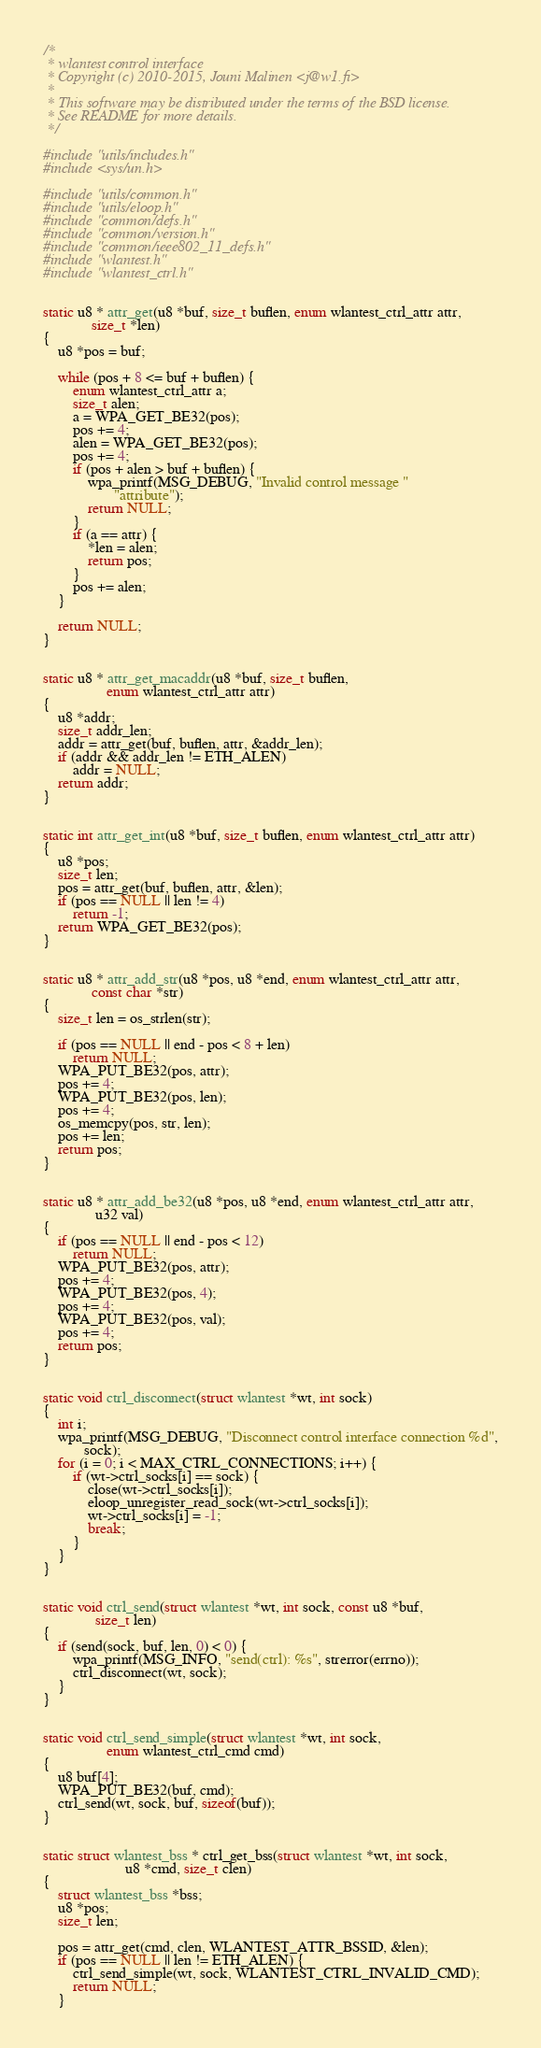<code> <loc_0><loc_0><loc_500><loc_500><_C_>/*
 * wlantest control interface
 * Copyright (c) 2010-2015, Jouni Malinen <j@w1.fi>
 *
 * This software may be distributed under the terms of the BSD license.
 * See README for more details.
 */

#include "utils/includes.h"
#include <sys/un.h>

#include "utils/common.h"
#include "utils/eloop.h"
#include "common/defs.h"
#include "common/version.h"
#include "common/ieee802_11_defs.h"
#include "wlantest.h"
#include "wlantest_ctrl.h"


static u8 * attr_get(u8 *buf, size_t buflen, enum wlantest_ctrl_attr attr,
		     size_t *len)
{
	u8 *pos = buf;

	while (pos + 8 <= buf + buflen) {
		enum wlantest_ctrl_attr a;
		size_t alen;
		a = WPA_GET_BE32(pos);
		pos += 4;
		alen = WPA_GET_BE32(pos);
		pos += 4;
		if (pos + alen > buf + buflen) {
			wpa_printf(MSG_DEBUG, "Invalid control message "
				   "attribute");
			return NULL;
		}
		if (a == attr) {
			*len = alen;
			return pos;
		}
		pos += alen;
	}

	return NULL;
}


static u8 * attr_get_macaddr(u8 *buf, size_t buflen,
			     enum wlantest_ctrl_attr attr)
{
	u8 *addr;
	size_t addr_len;
	addr = attr_get(buf, buflen, attr, &addr_len);
	if (addr && addr_len != ETH_ALEN)
		addr = NULL;
	return addr;
}


static int attr_get_int(u8 *buf, size_t buflen, enum wlantest_ctrl_attr attr)
{
	u8 *pos;
	size_t len;
	pos = attr_get(buf, buflen, attr, &len);
	if (pos == NULL || len != 4)
		return -1;
	return WPA_GET_BE32(pos);
}


static u8 * attr_add_str(u8 *pos, u8 *end, enum wlantest_ctrl_attr attr,
			 const char *str)
{
	size_t len = os_strlen(str);

	if (pos == NULL || end - pos < 8 + len)
		return NULL;
	WPA_PUT_BE32(pos, attr);
	pos += 4;
	WPA_PUT_BE32(pos, len);
	pos += 4;
	os_memcpy(pos, str, len);
	pos += len;
	return pos;
}


static u8 * attr_add_be32(u8 *pos, u8 *end, enum wlantest_ctrl_attr attr,
			  u32 val)
{
	if (pos == NULL || end - pos < 12)
		return NULL;
	WPA_PUT_BE32(pos, attr);
	pos += 4;
	WPA_PUT_BE32(pos, 4);
	pos += 4;
	WPA_PUT_BE32(pos, val);
	pos += 4;
	return pos;
}


static void ctrl_disconnect(struct wlantest *wt, int sock)
{
	int i;
	wpa_printf(MSG_DEBUG, "Disconnect control interface connection %d",
		   sock);
	for (i = 0; i < MAX_CTRL_CONNECTIONS; i++) {
		if (wt->ctrl_socks[i] == sock) {
			close(wt->ctrl_socks[i]);
			eloop_unregister_read_sock(wt->ctrl_socks[i]);
			wt->ctrl_socks[i] = -1;
			break;
		}
	}
}


static void ctrl_send(struct wlantest *wt, int sock, const u8 *buf,
		      size_t len)
{
	if (send(sock, buf, len, 0) < 0) {
		wpa_printf(MSG_INFO, "send(ctrl): %s", strerror(errno));
		ctrl_disconnect(wt, sock);
	}
}


static void ctrl_send_simple(struct wlantest *wt, int sock,
			     enum wlantest_ctrl_cmd cmd)
{
	u8 buf[4];
	WPA_PUT_BE32(buf, cmd);
	ctrl_send(wt, sock, buf, sizeof(buf));
}


static struct wlantest_bss * ctrl_get_bss(struct wlantest *wt, int sock,
					  u8 *cmd, size_t clen)
{
	struct wlantest_bss *bss;
	u8 *pos;
	size_t len;

	pos = attr_get(cmd, clen, WLANTEST_ATTR_BSSID, &len);
	if (pos == NULL || len != ETH_ALEN) {
		ctrl_send_simple(wt, sock, WLANTEST_CTRL_INVALID_CMD);
		return NULL;
	}
</code> 